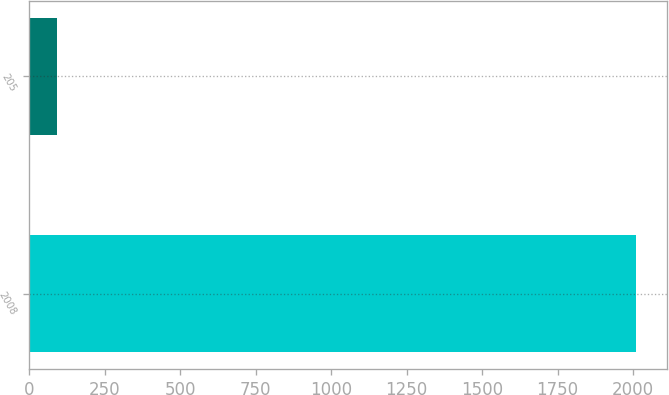<chart> <loc_0><loc_0><loc_500><loc_500><bar_chart><fcel>2008<fcel>205<nl><fcel>2011<fcel>91<nl></chart> 